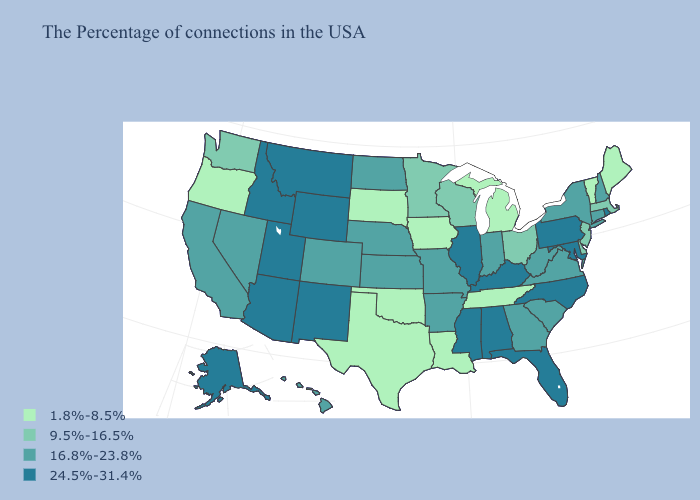Does the map have missing data?
Answer briefly. No. Among the states that border Alabama , does Florida have the lowest value?
Answer briefly. No. Which states have the lowest value in the South?
Write a very short answer. Tennessee, Louisiana, Oklahoma, Texas. What is the value of Massachusetts?
Keep it brief. 9.5%-16.5%. Name the states that have a value in the range 9.5%-16.5%?
Keep it brief. Massachusetts, New Jersey, Delaware, Ohio, Wisconsin, Minnesota, Washington. How many symbols are there in the legend?
Write a very short answer. 4. Does Vermont have the lowest value in the USA?
Answer briefly. Yes. Name the states that have a value in the range 16.8%-23.8%?
Answer briefly. New Hampshire, Connecticut, New York, Virginia, South Carolina, West Virginia, Georgia, Indiana, Missouri, Arkansas, Kansas, Nebraska, North Dakota, Colorado, Nevada, California, Hawaii. Does Wisconsin have a higher value than New Hampshire?
Be succinct. No. Name the states that have a value in the range 24.5%-31.4%?
Give a very brief answer. Rhode Island, Maryland, Pennsylvania, North Carolina, Florida, Kentucky, Alabama, Illinois, Mississippi, Wyoming, New Mexico, Utah, Montana, Arizona, Idaho, Alaska. Name the states that have a value in the range 1.8%-8.5%?
Quick response, please. Maine, Vermont, Michigan, Tennessee, Louisiana, Iowa, Oklahoma, Texas, South Dakota, Oregon. Name the states that have a value in the range 24.5%-31.4%?
Short answer required. Rhode Island, Maryland, Pennsylvania, North Carolina, Florida, Kentucky, Alabama, Illinois, Mississippi, Wyoming, New Mexico, Utah, Montana, Arizona, Idaho, Alaska. Name the states that have a value in the range 9.5%-16.5%?
Give a very brief answer. Massachusetts, New Jersey, Delaware, Ohio, Wisconsin, Minnesota, Washington. What is the value of Pennsylvania?
Keep it brief. 24.5%-31.4%. 